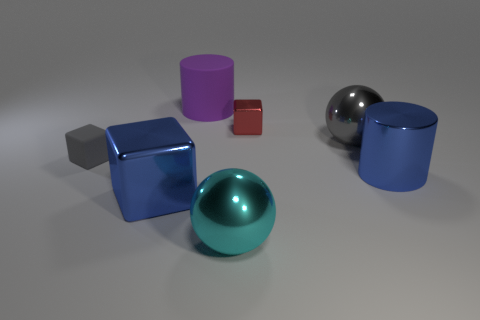Add 2 tiny purple cylinders. How many objects exist? 9 Subtract all cubes. How many objects are left? 4 Subtract all blue rubber balls. Subtract all tiny gray blocks. How many objects are left? 6 Add 6 rubber things. How many rubber things are left? 8 Add 5 big brown cylinders. How many big brown cylinders exist? 5 Subtract 1 cyan balls. How many objects are left? 6 